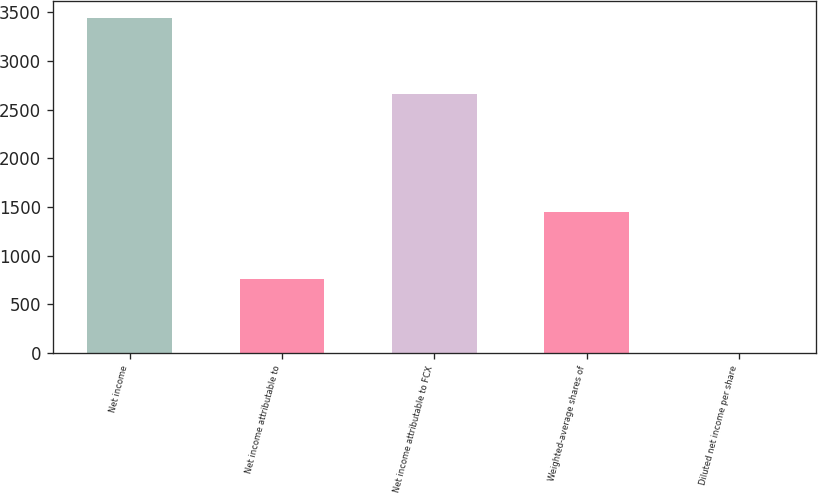Convert chart. <chart><loc_0><loc_0><loc_500><loc_500><bar_chart><fcel>Net income<fcel>Net income attributable to<fcel>Net income attributable to FCX<fcel>Weighted-average shares of<fcel>Diluted net income per share<nl><fcel>3441<fcel>761<fcel>2658<fcel>1448.68<fcel>2.64<nl></chart> 